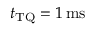<formula> <loc_0><loc_0><loc_500><loc_500>t _ { T Q } = 1 { \, m s }</formula> 